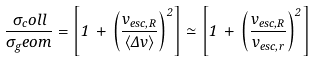<formula> <loc_0><loc_0><loc_500><loc_500>\frac { \sigma _ { c } o l l } { \sigma _ { g } e o m } = \left [ 1 \, + \, \left ( \frac { v _ { e s c , R } } { \langle \Delta v \rangle } \right ) ^ { 2 } \right ] \simeq \left [ 1 \, + \, \left ( \frac { v _ { e s c , R } } { v _ { e s c , r } } \right ) ^ { 2 } \right ]</formula> 